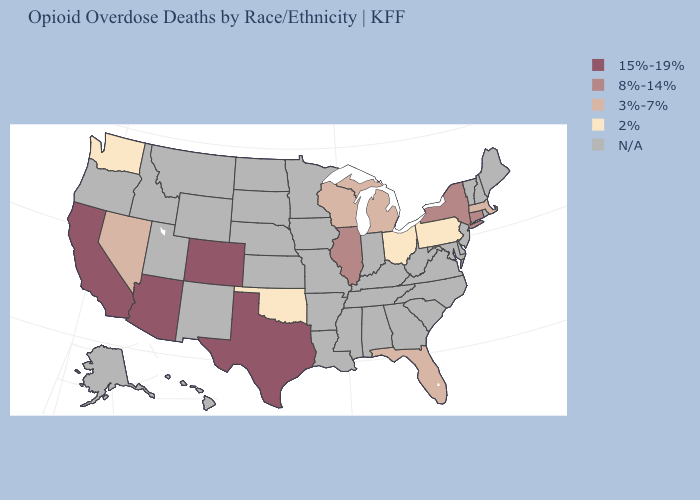Which states have the highest value in the USA?
Give a very brief answer. Arizona, California, Colorado, Texas. Which states have the lowest value in the USA?
Give a very brief answer. Ohio, Oklahoma, Pennsylvania, Washington. Name the states that have a value in the range 3%-7%?
Be succinct. Florida, Massachusetts, Michigan, Nevada, Wisconsin. Among the states that border New Hampshire , which have the lowest value?
Quick response, please. Massachusetts. Name the states that have a value in the range 2%?
Short answer required. Ohio, Oklahoma, Pennsylvania, Washington. What is the value of Oregon?
Give a very brief answer. N/A. What is the lowest value in the USA?
Write a very short answer. 2%. Name the states that have a value in the range N/A?
Quick response, please. Alabama, Alaska, Arkansas, Delaware, Georgia, Hawaii, Idaho, Indiana, Iowa, Kansas, Kentucky, Louisiana, Maine, Maryland, Minnesota, Mississippi, Missouri, Montana, Nebraska, New Hampshire, New Jersey, New Mexico, North Carolina, North Dakota, Oregon, Rhode Island, South Carolina, South Dakota, Tennessee, Utah, Vermont, Virginia, West Virginia, Wyoming. Does Pennsylvania have the lowest value in the USA?
Keep it brief. Yes. What is the lowest value in the Northeast?
Be succinct. 2%. What is the highest value in states that border Oklahoma?
Give a very brief answer. 15%-19%. Does Nevada have the lowest value in the USA?
Quick response, please. No. What is the value of Michigan?
Short answer required. 3%-7%. Does Pennsylvania have the lowest value in the Northeast?
Concise answer only. Yes. 